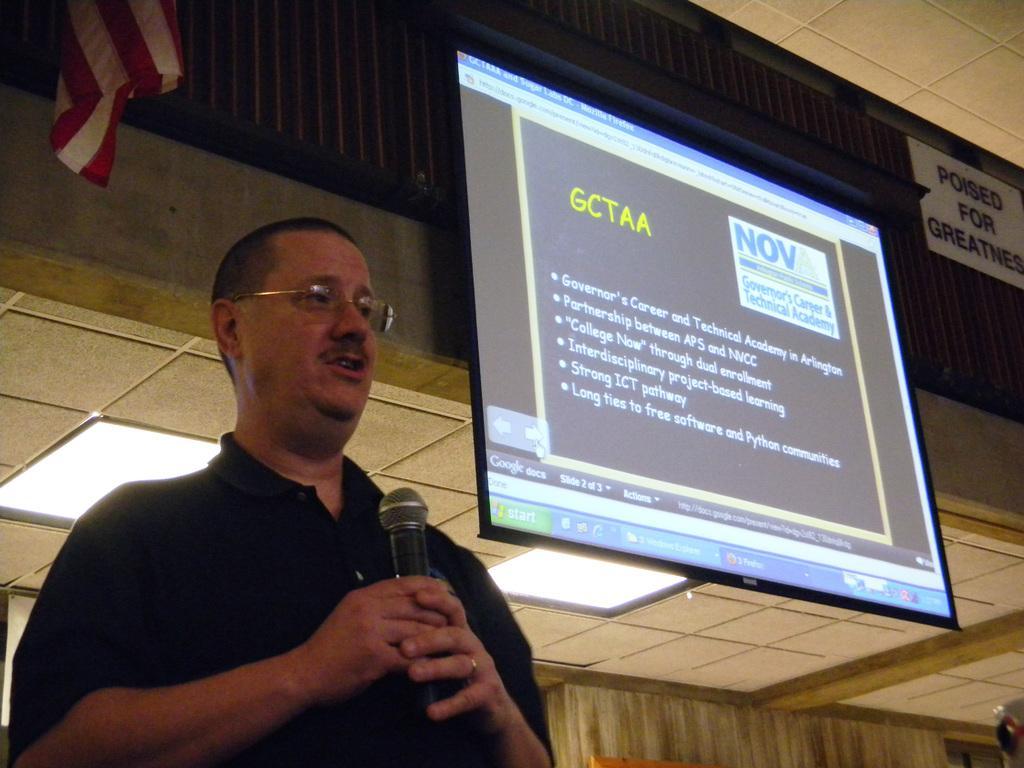In one or two sentences, can you explain what this image depicts? In this Image I can see the person standing and wearing the black color dress and he is holding the mic. To the right there is a screen and I can see the board and flag to the wall. There are lights in the top. 